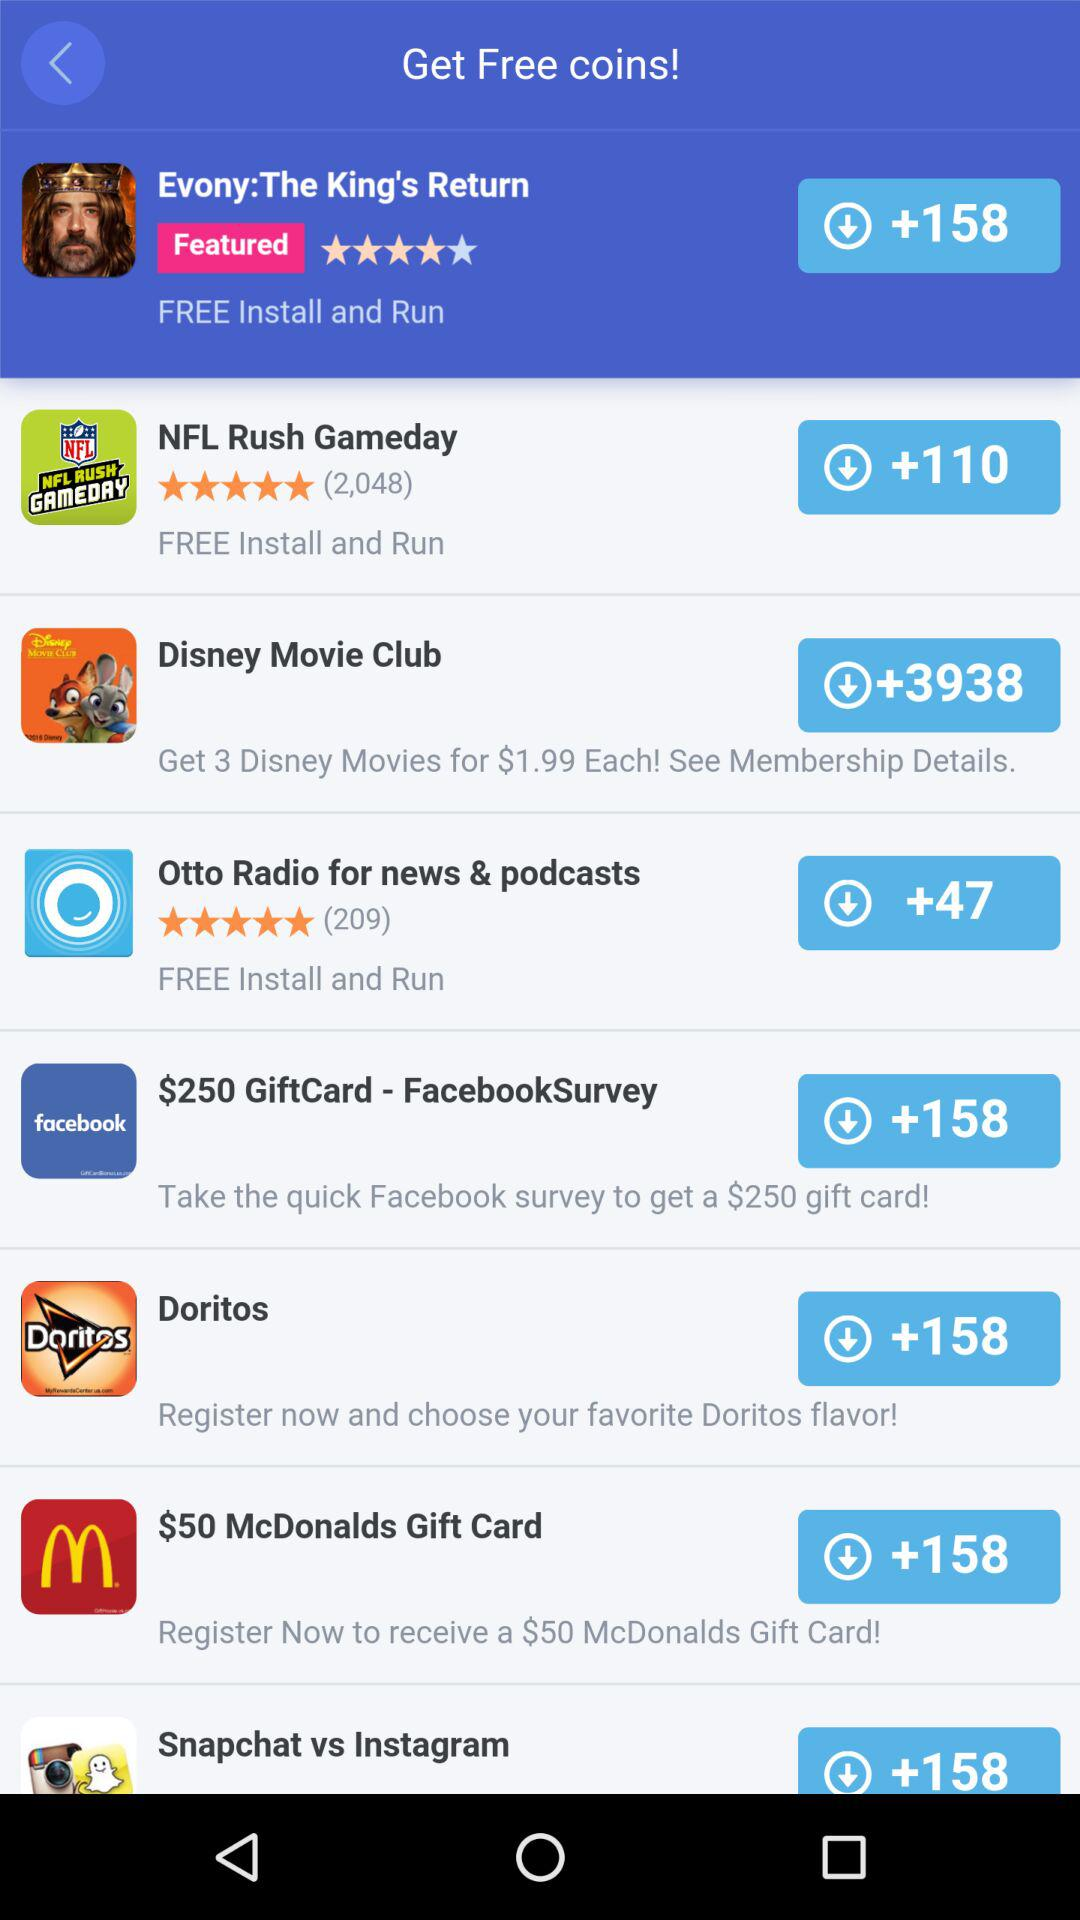How many downloaded Doritos?
When the provided information is insufficient, respond with <no answer>. <no answer> 